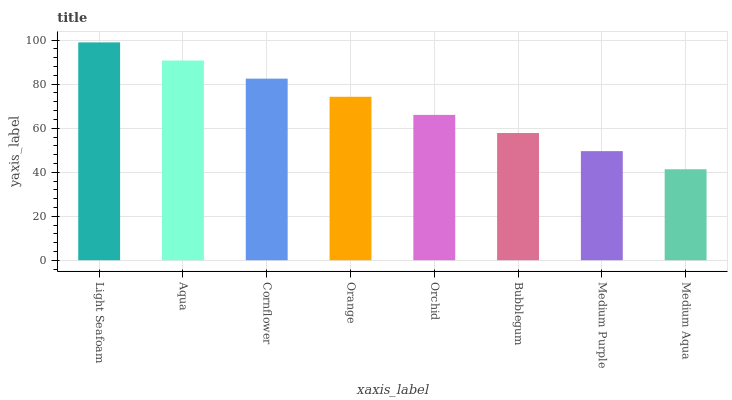Is Medium Aqua the minimum?
Answer yes or no. Yes. Is Light Seafoam the maximum?
Answer yes or no. Yes. Is Aqua the minimum?
Answer yes or no. No. Is Aqua the maximum?
Answer yes or no. No. Is Light Seafoam greater than Aqua?
Answer yes or no. Yes. Is Aqua less than Light Seafoam?
Answer yes or no. Yes. Is Aqua greater than Light Seafoam?
Answer yes or no. No. Is Light Seafoam less than Aqua?
Answer yes or no. No. Is Orange the high median?
Answer yes or no. Yes. Is Orchid the low median?
Answer yes or no. Yes. Is Orchid the high median?
Answer yes or no. No. Is Aqua the low median?
Answer yes or no. No. 